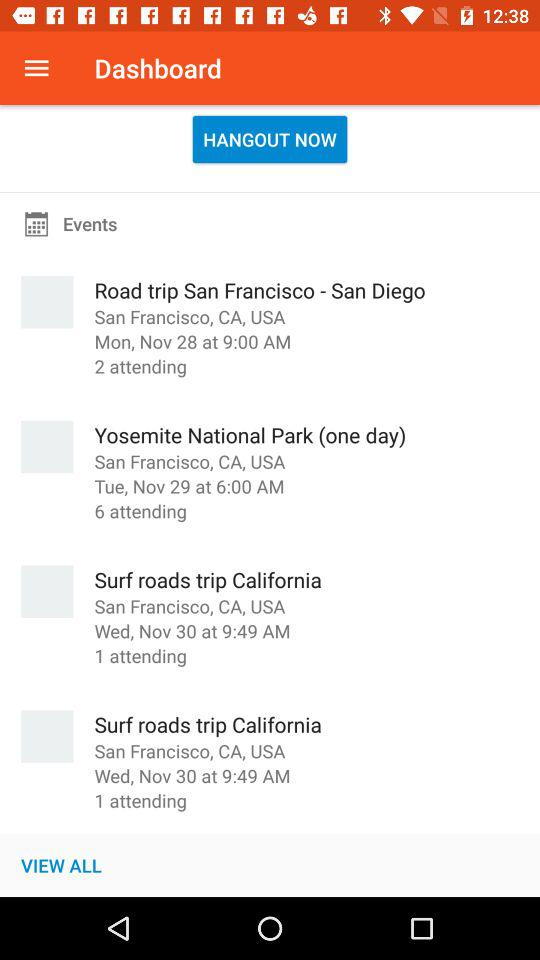How many people will be attending "Road trip San Francisco - San Diego"? It will be attended by 2 people. 